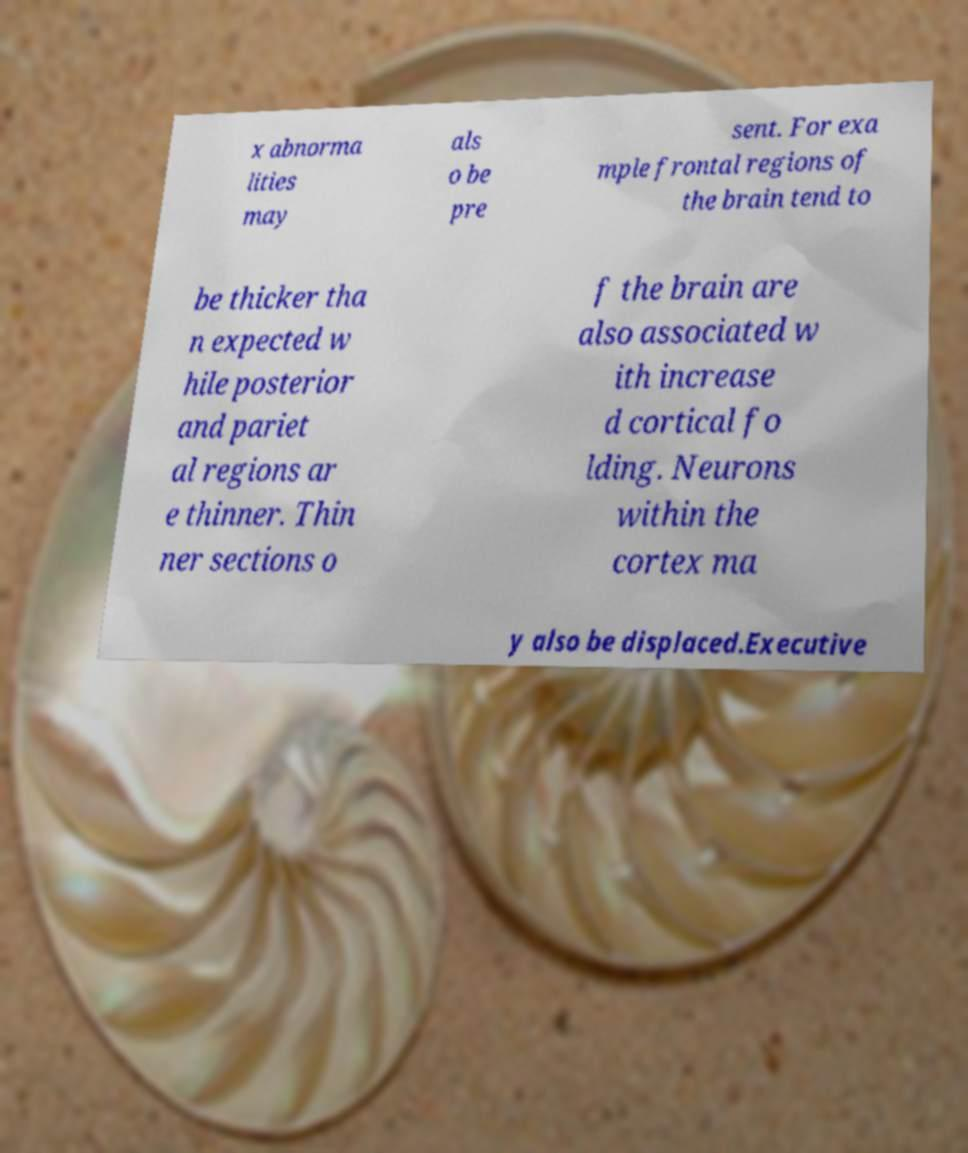Could you assist in decoding the text presented in this image and type it out clearly? x abnorma lities may als o be pre sent. For exa mple frontal regions of the brain tend to be thicker tha n expected w hile posterior and pariet al regions ar e thinner. Thin ner sections o f the brain are also associated w ith increase d cortical fo lding. Neurons within the cortex ma y also be displaced.Executive 